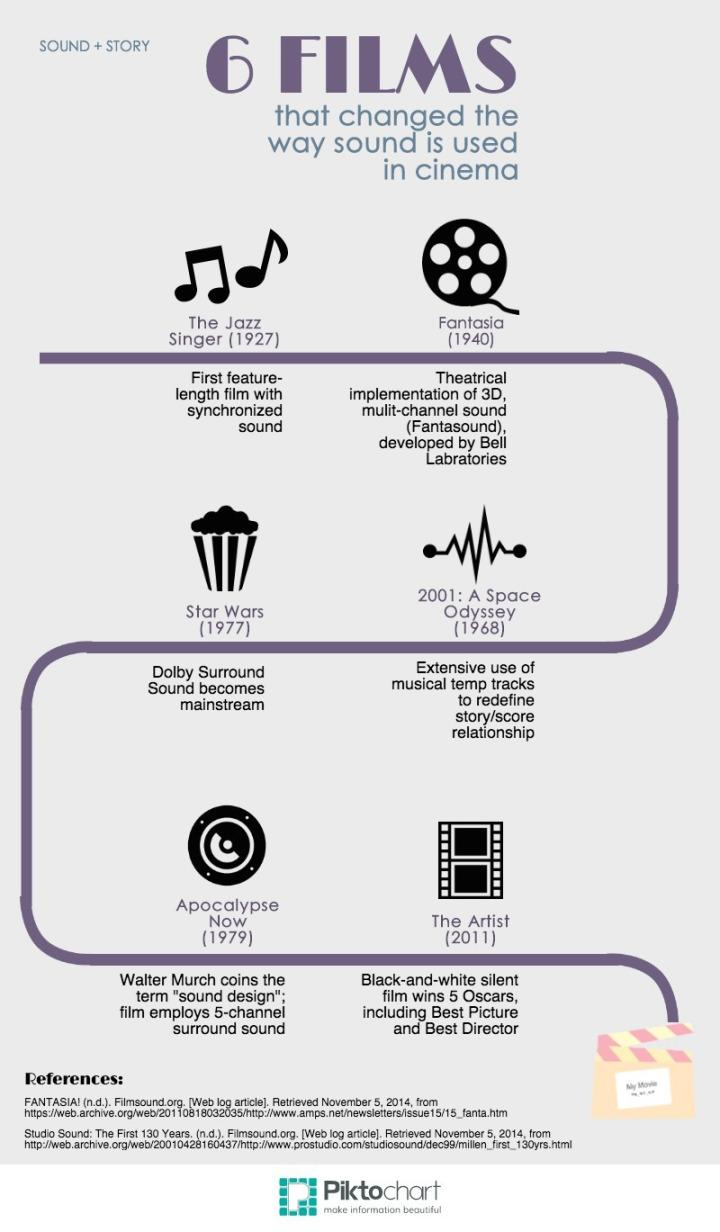Give some essential details in this illustration. The film released in 1977 that utilized Dolby sound effects was "Star Wars. The movie 'The Artist' was released in 2011. The movie 'Fantasia' was released in 1940. The Jazz Singer was the first feature-length film released with synchronized sound. 